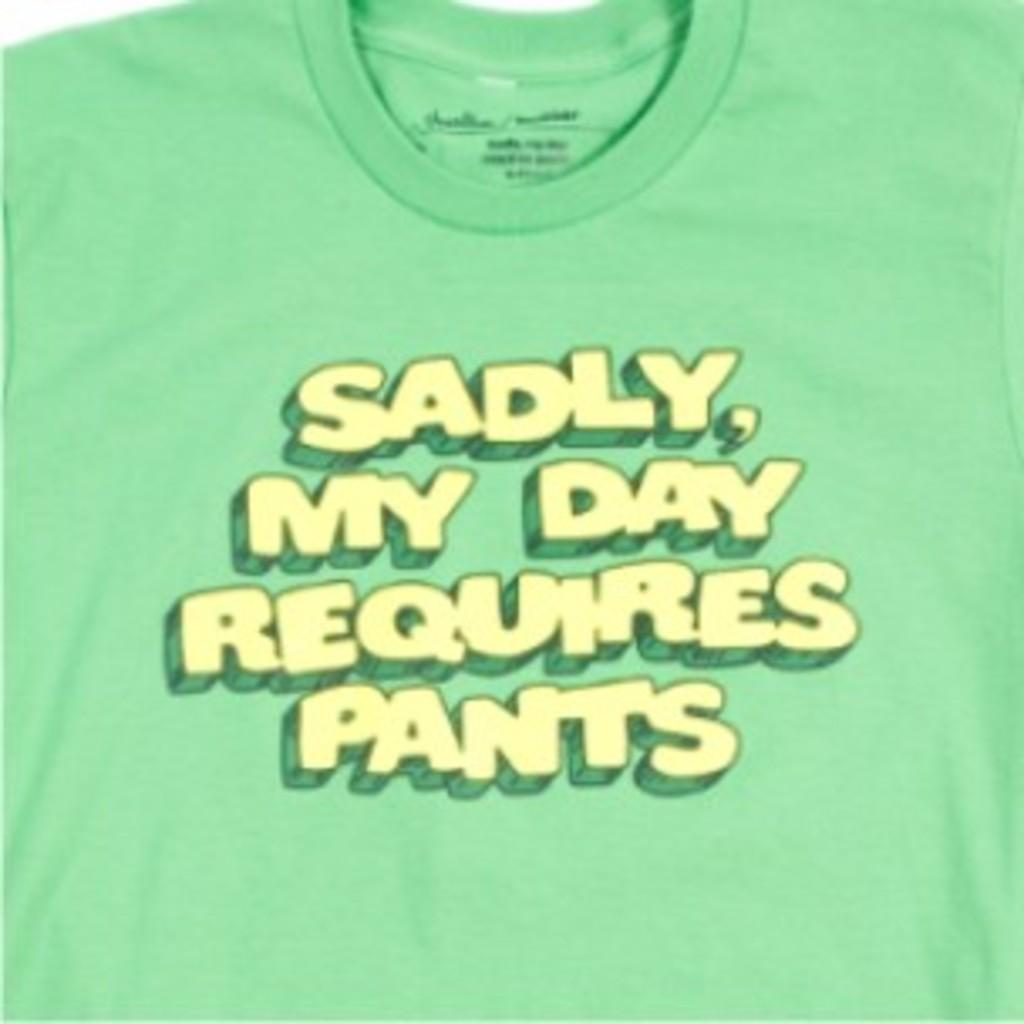What color is the T-shirt in the image? There is a green T-shirt in the image. What is written or printed on the T-shirt? There is some text on the green T-shirt. What type of smell is associated with the green T-shirt in the image? There is no indication of a smell associated with the green T-shirt in the image. Is there a gold wheel attached to the green T-shirt in the image? There is no wheel, gold or otherwise, attached to the green T-shirt in the image. 